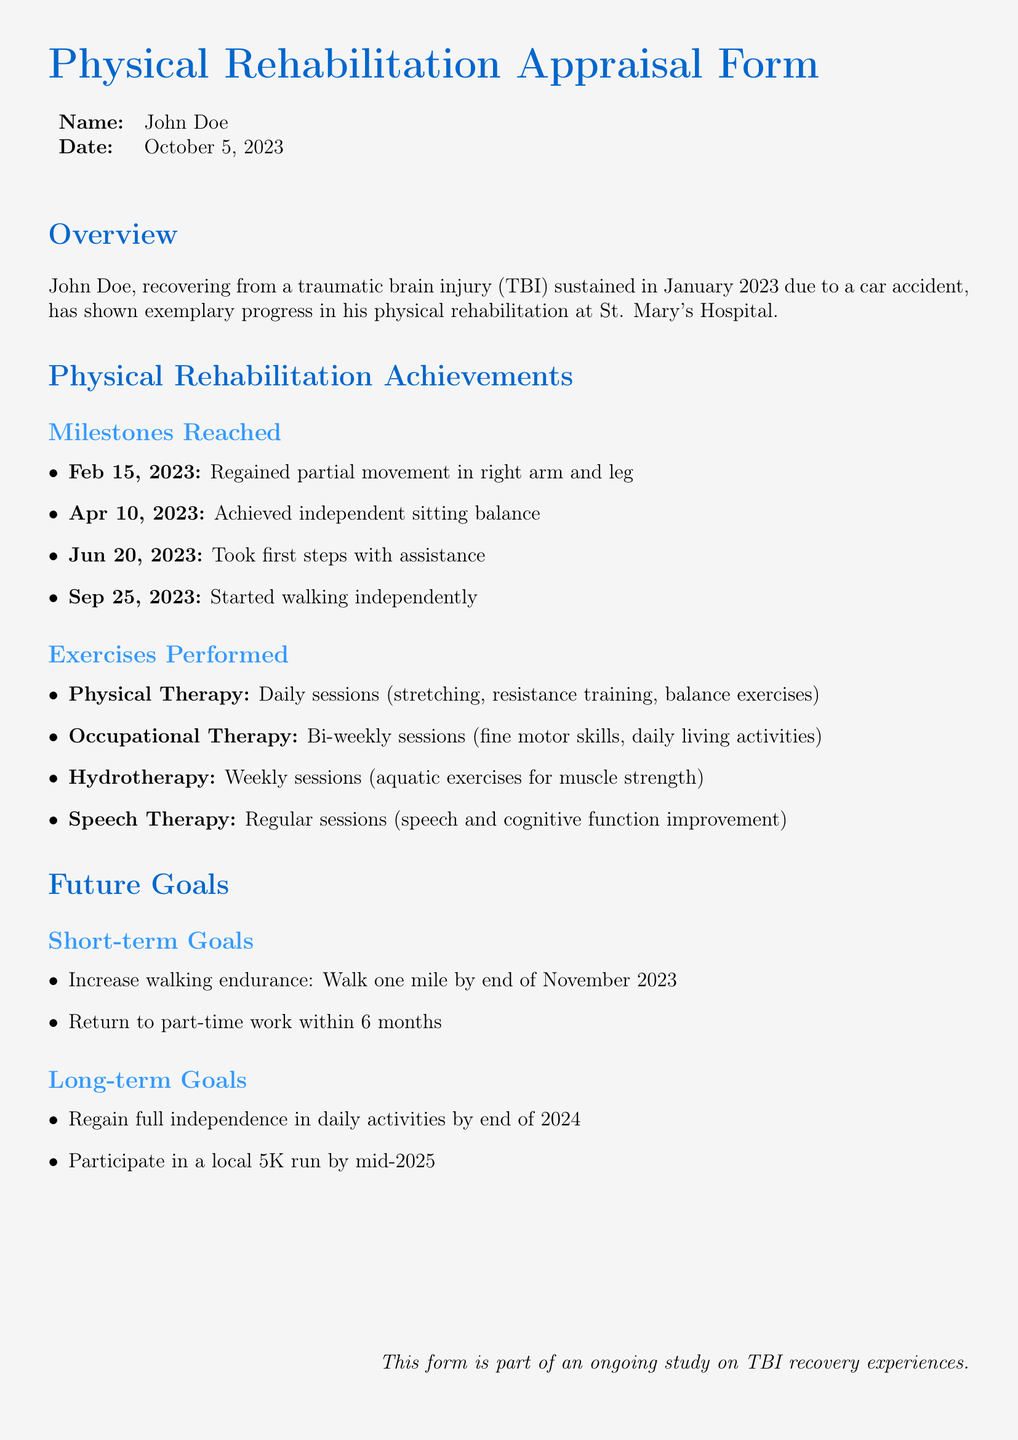What is the name of the patient? The name of the patient is mentioned clearly at the top of the document and is "John Doe."
Answer: John Doe What date was the appraisal form filled out? The date of the appraisal form is provided in a tabular format, stating "October 5, 2023."
Answer: October 5, 2023 When did the patient achieve independent sitting balance? The date when the patient achieved independent sitting balance is included under milestones, which is "Apr 10, 2023."
Answer: Apr 10, 2023 What was the first milestone reached by the patient? The first milestone reached by the patient is noted in the list of milestones, which is "Regained partial movement in right arm and leg."
Answer: Regained partial movement in right arm and leg How often does the patient attend hydrotherapy sessions? The document specifies that hydrotherapy sessions are performed weekly, outlining the frequency of this exercise.
Answer: Weekly What is the patient's short-term goal for walking endurance? The document outlines the patient's short-term goal, which is to "Walk one mile by end of November 2023."
Answer: Walk one mile by end of November 2023 What are the focus areas of occupational therapy sessions? The areas of focus for occupational therapy are detailed in the exercises section, emphasizing "fine motor skills, daily living activities."
Answer: Fine motor skills, daily living activities What is the long-term goal regarding independence? The document lists a specific long-term goal for the patient, which is "Regain full independence in daily activities by end of 2024."
Answer: Regain full independence in daily activities by end of 2024 What is the title of the document? The title is prominently displayed at the top of the document, explicitly stating "Physical Rehabilitation Appraisal Form."
Answer: Physical Rehabilitation Appraisal Form 